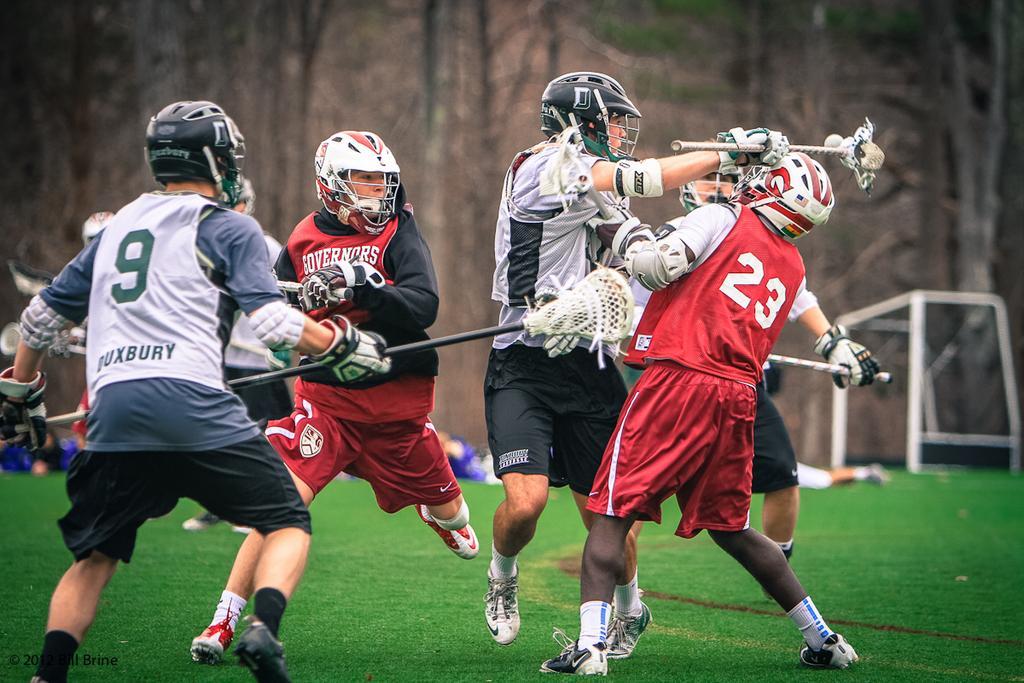How would you summarize this image in a sentence or two? This picture is consists of field lacrosse in the image and there are players in the center of the image on the grassland and there are other people and a net in the background area of the image. 